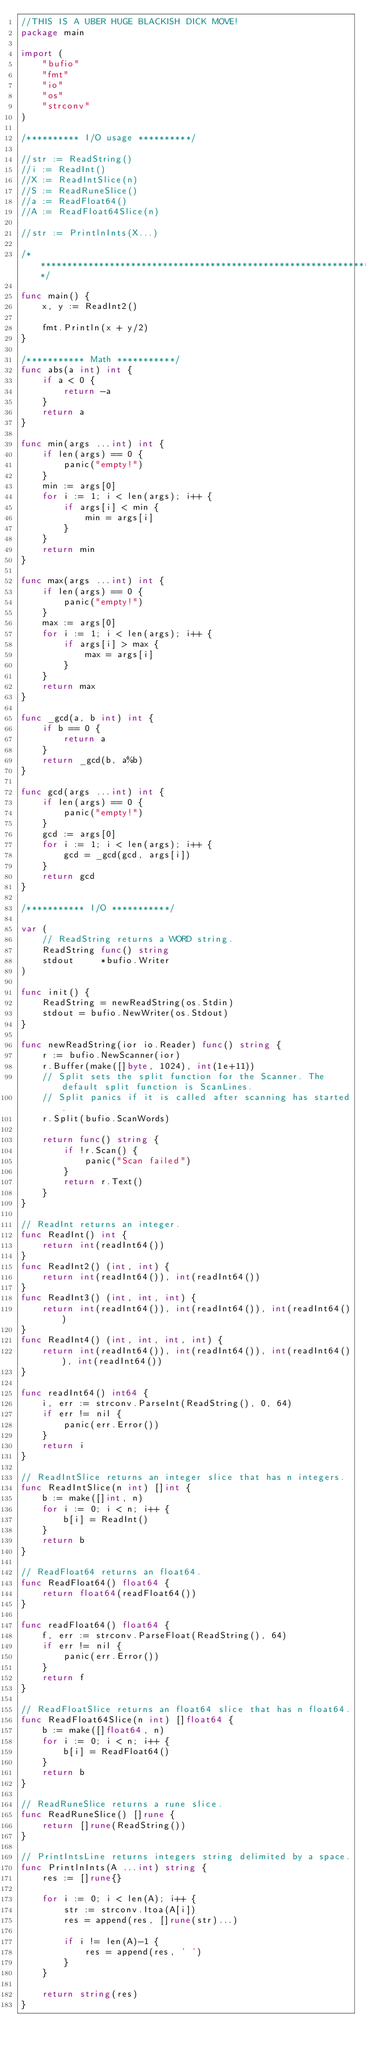Convert code to text. <code><loc_0><loc_0><loc_500><loc_500><_Go_>//THIS IS A UBER HUGE BLACKISH DICK MOVE!
package main

import (
	"bufio"
	"fmt"
	"io"
	"os"
	"strconv"
)

/********** I/O usage **********/

//str := ReadString()
//i := ReadInt()
//X := ReadIntSlice(n)
//S := ReadRuneSlice()
//a := ReadFloat64()
//A := ReadFloat64Slice(n)

//str := PrintlnInts(X...)

/*******************************************************************/

func main() {
	x, y := ReadInt2()

	fmt.Println(x + y/2)
}

/*********** Math ***********/
func abs(a int) int {
	if a < 0 {
		return -a
	}
	return a
}

func min(args ...int) int {
	if len(args) == 0 {
		panic("empty!")
	}
	min := args[0]
	for i := 1; i < len(args); i++ {
		if args[i] < min {
			min = args[i]
		}
	}
	return min
}

func max(args ...int) int {
	if len(args) == 0 {
		panic("empty!")
	}
	max := args[0]
	for i := 1; i < len(args); i++ {
		if args[i] > max {
			max = args[i]
		}
	}
	return max
}

func _gcd(a, b int) int {
	if b == 0 {
		return a
	}
	return _gcd(b, a%b)
}

func gcd(args ...int) int {
	if len(args) == 0 {
		panic("empty!")
	}
	gcd := args[0]
	for i := 1; i < len(args); i++ {
		gcd = _gcd(gcd, args[i])
	}
	return gcd
}

/*********** I/O ***********/

var (
	// ReadString returns a WORD string.
	ReadString func() string
	stdout     *bufio.Writer
)

func init() {
	ReadString = newReadString(os.Stdin)
	stdout = bufio.NewWriter(os.Stdout)
}

func newReadString(ior io.Reader) func() string {
	r := bufio.NewScanner(ior)
	r.Buffer(make([]byte, 1024), int(1e+11))
	// Split sets the split function for the Scanner. The default split function is ScanLines.
	// Split panics if it is called after scanning has started.
	r.Split(bufio.ScanWords)

	return func() string {
		if !r.Scan() {
			panic("Scan failed")
		}
		return r.Text()
	}
}

// ReadInt returns an integer.
func ReadInt() int {
	return int(readInt64())
}
func ReadInt2() (int, int) {
	return int(readInt64()), int(readInt64())
}
func ReadInt3() (int, int, int) {
	return int(readInt64()), int(readInt64()), int(readInt64())
}
func ReadInt4() (int, int, int, int) {
	return int(readInt64()), int(readInt64()), int(readInt64()), int(readInt64())
}

func readInt64() int64 {
	i, err := strconv.ParseInt(ReadString(), 0, 64)
	if err != nil {
		panic(err.Error())
	}
	return i
}

// ReadIntSlice returns an integer slice that has n integers.
func ReadIntSlice(n int) []int {
	b := make([]int, n)
	for i := 0; i < n; i++ {
		b[i] = ReadInt()
	}
	return b
}

// ReadFloat64 returns an float64.
func ReadFloat64() float64 {
	return float64(readFloat64())
}

func readFloat64() float64 {
	f, err := strconv.ParseFloat(ReadString(), 64)
	if err != nil {
		panic(err.Error())
	}
	return f
}

// ReadFloatSlice returns an float64 slice that has n float64.
func ReadFloat64Slice(n int) []float64 {
	b := make([]float64, n)
	for i := 0; i < n; i++ {
		b[i] = ReadFloat64()
	}
	return b
}

// ReadRuneSlice returns a rune slice.
func ReadRuneSlice() []rune {
	return []rune(ReadString())
}

// PrintIntsLine returns integers string delimited by a space.
func PrintlnInts(A ...int) string {
	res := []rune{}

	for i := 0; i < len(A); i++ {
		str := strconv.Itoa(A[i])
		res = append(res, []rune(str)...)

		if i != len(A)-1 {
			res = append(res, ' ')
		}
	}

	return string(res)
}
</code> 